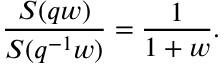Convert formula to latex. <formula><loc_0><loc_0><loc_500><loc_500>\frac { S ( q w ) } { S ( q ^ { - 1 } w ) } = \frac { 1 } { 1 + w } .</formula> 